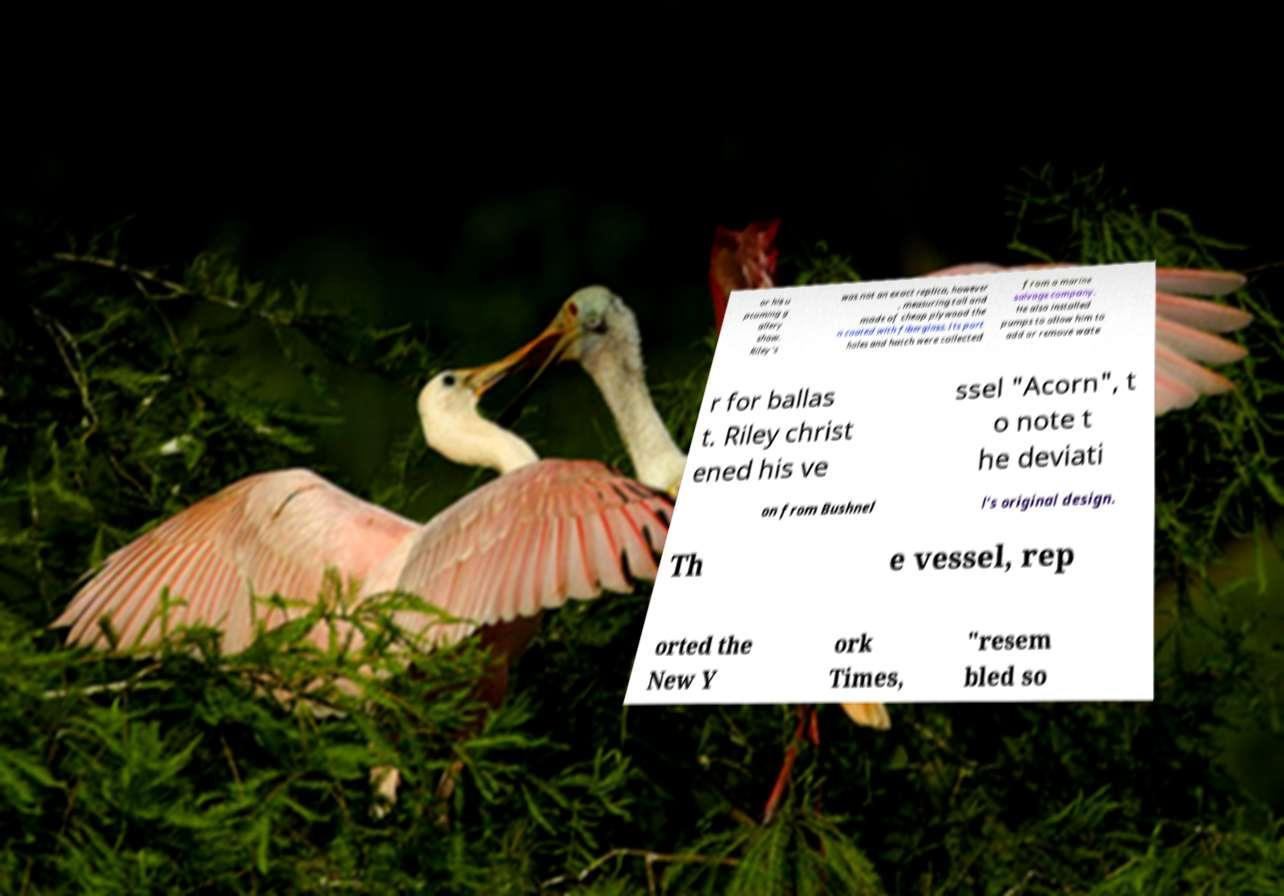Can you accurately transcribe the text from the provided image for me? or his u pcoming g allery show. Riley's was not an exact replica, however , measuring tall and made of cheap plywood the n coated with fiberglass. Its port holes and hatch were collected from a marine salvage company. He also installed pumps to allow him to add or remove wate r for ballas t. Riley christ ened his ve ssel "Acorn", t o note t he deviati on from Bushnel l's original design. Th e vessel, rep orted the New Y ork Times, "resem bled so 